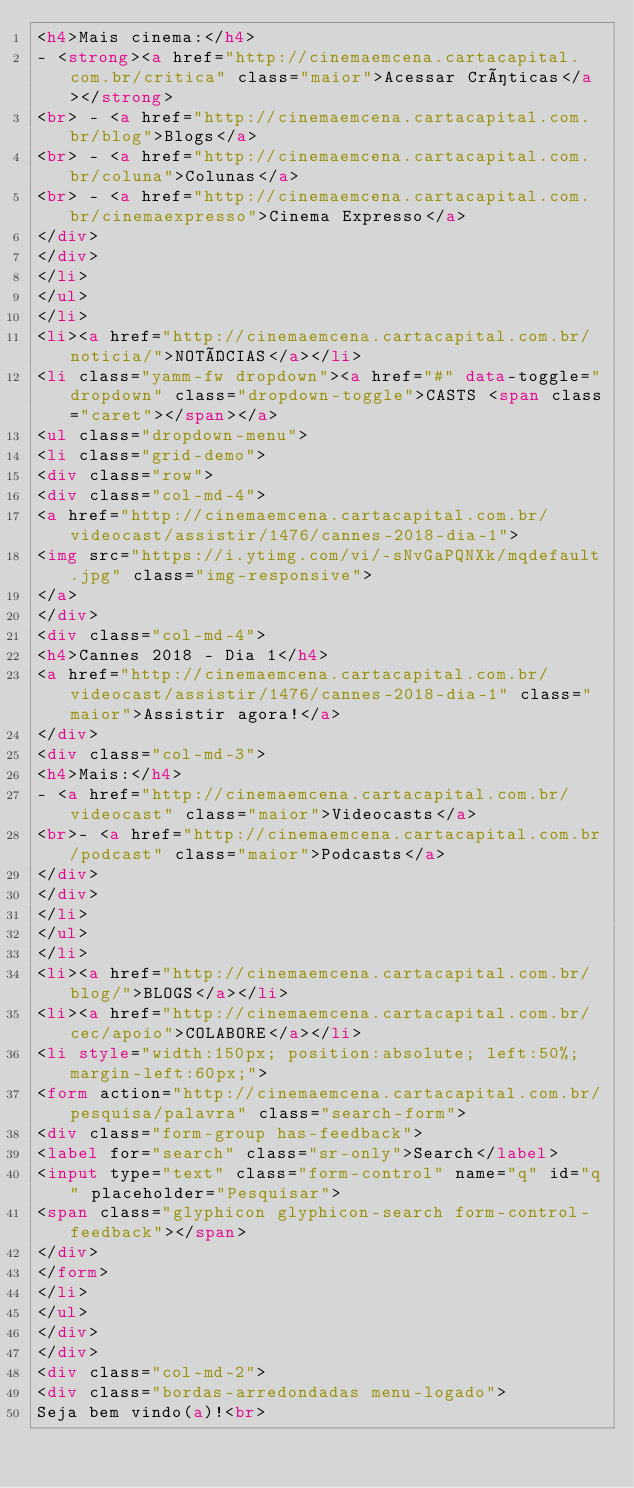<code> <loc_0><loc_0><loc_500><loc_500><_HTML_><h4>Mais cinema:</h4>
- <strong><a href="http://cinemaemcena.cartacapital.com.br/critica" class="maior">Acessar Críticas</a></strong>
<br> - <a href="http://cinemaemcena.cartacapital.com.br/blog">Blogs</a>
<br> - <a href="http://cinemaemcena.cartacapital.com.br/coluna">Colunas</a>
<br> - <a href="http://cinemaemcena.cartacapital.com.br/cinemaexpresso">Cinema Expresso</a>
</div>
</div>
</li>
</ul>
</li>
<li><a href="http://cinemaemcena.cartacapital.com.br/noticia/">NOTÍCIAS</a></li>
<li class="yamm-fw dropdown"><a href="#" data-toggle="dropdown" class="dropdown-toggle">CASTS <span class="caret"></span></a>
<ul class="dropdown-menu">
<li class="grid-demo">
<div class="row">
<div class="col-md-4">
<a href="http://cinemaemcena.cartacapital.com.br/videocast/assistir/1476/cannes-2018-dia-1">
<img src="https://i.ytimg.com/vi/-sNvGaPQNXk/mqdefault.jpg" class="img-responsive">
</a>
</div>
<div class="col-md-4">
<h4>Cannes 2018 - Dia 1</h4>
<a href="http://cinemaemcena.cartacapital.com.br/videocast/assistir/1476/cannes-2018-dia-1" class="maior">Assistir agora!</a>
</div>
<div class="col-md-3">
<h4>Mais:</h4>
- <a href="http://cinemaemcena.cartacapital.com.br/videocast" class="maior">Videocasts</a>
<br>- <a href="http://cinemaemcena.cartacapital.com.br/podcast" class="maior">Podcasts</a>
</div>
</div>
</li>
</ul>
</li>
<li><a href="http://cinemaemcena.cartacapital.com.br/blog/">BLOGS</a></li>
<li><a href="http://cinemaemcena.cartacapital.com.br/cec/apoio">COLABORE</a></li>
<li style="width:150px; position:absolute; left:50%; margin-left:60px;">
<form action="http://cinemaemcena.cartacapital.com.br/pesquisa/palavra" class="search-form">
<div class="form-group has-feedback">
<label for="search" class="sr-only">Search</label>
<input type="text" class="form-control" name="q" id="q" placeholder="Pesquisar">
<span class="glyphicon glyphicon-search form-control-feedback"></span>
</div>
</form>
</li>
</ul>
</div>
</div>
<div class="col-md-2">
<div class="bordas-arredondadas menu-logado">
Seja bem vindo(a)!<br></code> 